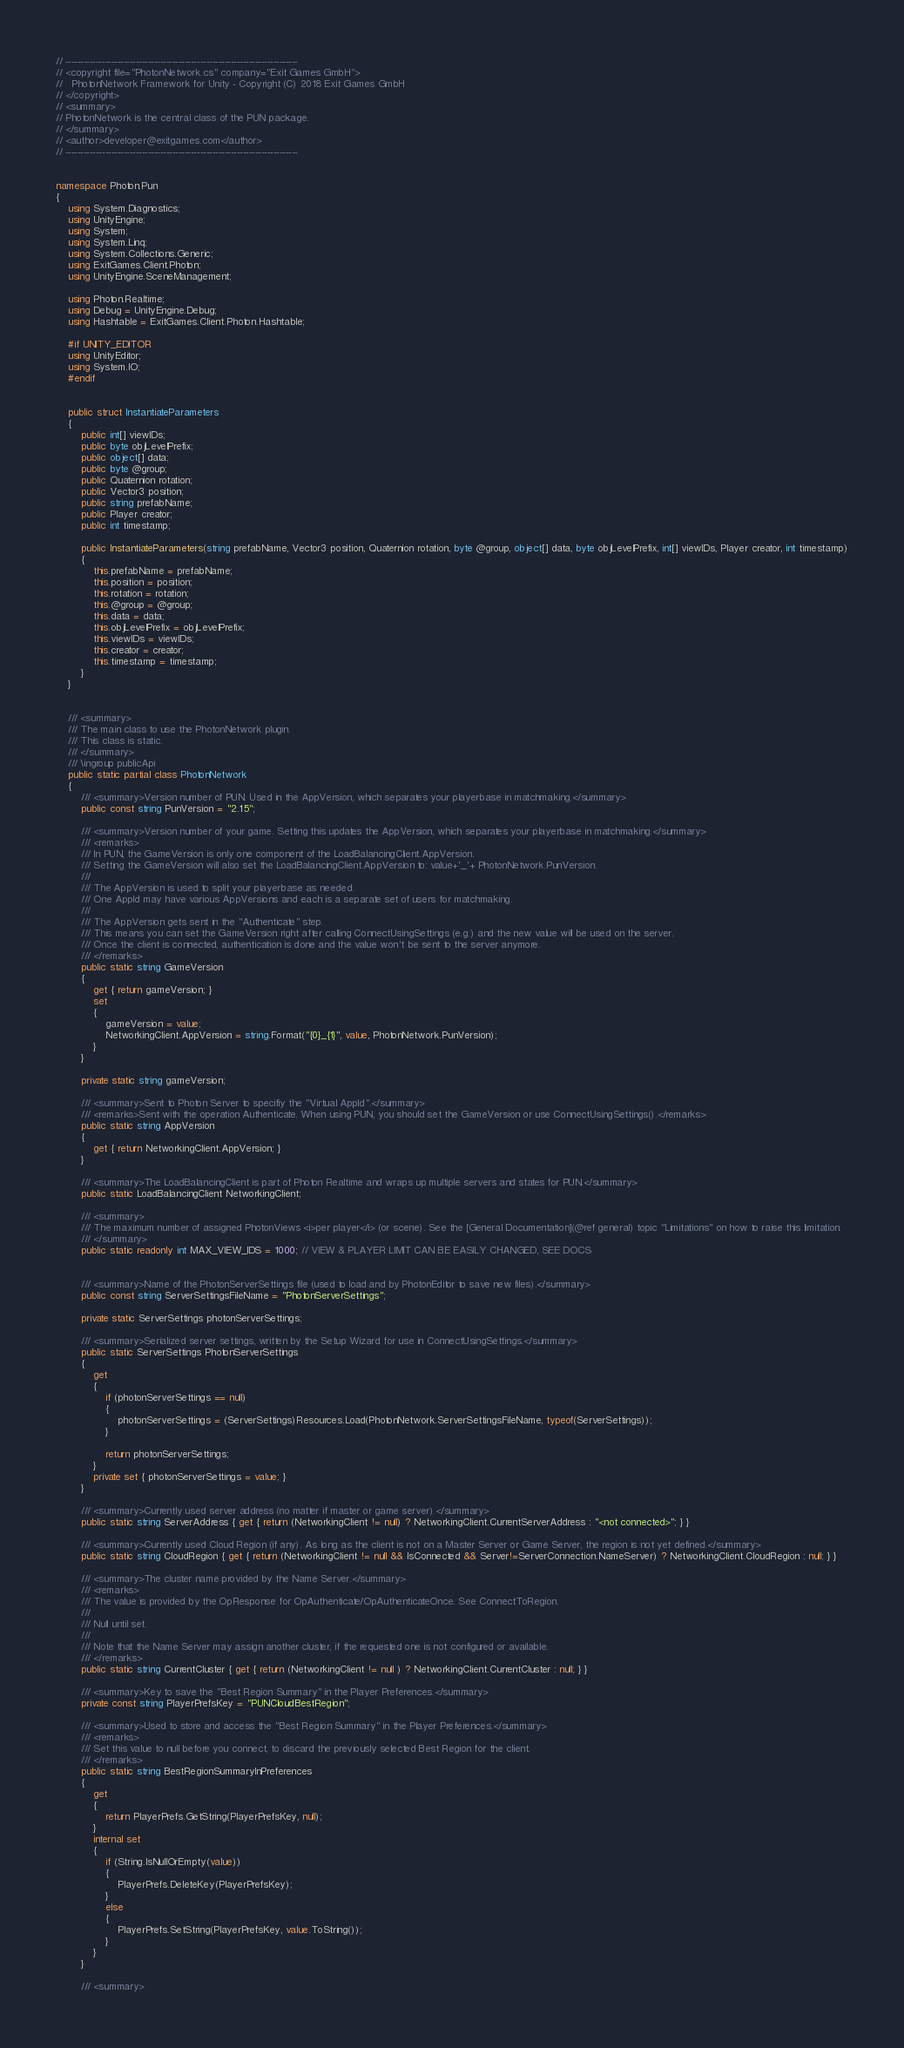Convert code to text. <code><loc_0><loc_0><loc_500><loc_500><_C#_>// ----------------------------------------------------------------------------
// <copyright file="PhotonNetwork.cs" company="Exit Games GmbH">
//   PhotonNetwork Framework for Unity - Copyright (C) 2018 Exit Games GmbH
// </copyright>
// <summary>
// PhotonNetwork is the central class of the PUN package.
// </summary>
// <author>developer@exitgames.com</author>
// ----------------------------------------------------------------------------


namespace Photon.Pun
{
    using System.Diagnostics;
    using UnityEngine;
    using System;
    using System.Linq;
    using System.Collections.Generic;
    using ExitGames.Client.Photon;
    using UnityEngine.SceneManagement;

    using Photon.Realtime;
    using Debug = UnityEngine.Debug;
    using Hashtable = ExitGames.Client.Photon.Hashtable;

    #if UNITY_EDITOR
    using UnityEditor;
    using System.IO;
    #endif


    public struct InstantiateParameters
    {
        public int[] viewIDs;
        public byte objLevelPrefix;
        public object[] data;
        public byte @group;
        public Quaternion rotation;
        public Vector3 position;
        public string prefabName;
        public Player creator;
        public int timestamp;

        public InstantiateParameters(string prefabName, Vector3 position, Quaternion rotation, byte @group, object[] data, byte objLevelPrefix, int[] viewIDs, Player creator, int timestamp)
        {
            this.prefabName = prefabName;
            this.position = position;
            this.rotation = rotation;
            this.@group = @group;
            this.data = data;
            this.objLevelPrefix = objLevelPrefix;
            this.viewIDs = viewIDs;
            this.creator = creator;
            this.timestamp = timestamp;
        }
    }


    /// <summary>
    /// The main class to use the PhotonNetwork plugin.
    /// This class is static.
    /// </summary>
    /// \ingroup publicApi
    public static partial class PhotonNetwork
    {
        /// <summary>Version number of PUN. Used in the AppVersion, which separates your playerbase in matchmaking.</summary>
        public const string PunVersion = "2.15";

        /// <summary>Version number of your game. Setting this updates the AppVersion, which separates your playerbase in matchmaking.</summary>
        /// <remarks>
        /// In PUN, the GameVersion is only one component of the LoadBalancingClient.AppVersion.
        /// Setting the GameVersion will also set the LoadBalancingClient.AppVersion to: value+'_'+ PhotonNetwork.PunVersion.
        ///
        /// The AppVersion is used to split your playerbase as needed.
        /// One AppId may have various AppVersions and each is a separate set of users for matchmaking.
        ///
        /// The AppVersion gets sent in the "Authenticate" step.
        /// This means you can set the GameVersion right after calling ConnectUsingSettings (e.g.) and the new value will be used on the server.
        /// Once the client is connected, authentication is done and the value won't be sent to the server anymore.
        /// </remarks>
        public static string GameVersion
        {
            get { return gameVersion; }
            set
            {
                gameVersion = value;
                NetworkingClient.AppVersion = string.Format("{0}_{1}", value, PhotonNetwork.PunVersion);
            }
        }

        private static string gameVersion;

        /// <summary>Sent to Photon Server to specifiy the "Virtual AppId".</summary>
        /// <remarks>Sent with the operation Authenticate. When using PUN, you should set the GameVersion or use ConnectUsingSettings().</remarks>
        public static string AppVersion
        {
            get { return NetworkingClient.AppVersion; }
        }

        /// <summary>The LoadBalancingClient is part of Photon Realtime and wraps up multiple servers and states for PUN.</summary>
        public static LoadBalancingClient NetworkingClient;

        /// <summary>
        /// The maximum number of assigned PhotonViews <i>per player</i> (or scene). See the [General Documentation](@ref general) topic "Limitations" on how to raise this limitation.
        /// </summary>
        public static readonly int MAX_VIEW_IDS = 1000; // VIEW & PLAYER LIMIT CAN BE EASILY CHANGED, SEE DOCS


        /// <summary>Name of the PhotonServerSettings file (used to load and by PhotonEditor to save new files).</summary>
        public const string ServerSettingsFileName = "PhotonServerSettings";

        private static ServerSettings photonServerSettings;

        /// <summary>Serialized server settings, written by the Setup Wizard for use in ConnectUsingSettings.</summary>
        public static ServerSettings PhotonServerSettings
        {
            get
            {
                if (photonServerSettings == null)
                {
                    photonServerSettings = (ServerSettings)Resources.Load(PhotonNetwork.ServerSettingsFileName, typeof(ServerSettings));
                }

                return photonServerSettings;
            }
            private set { photonServerSettings = value; }
        }

        /// <summary>Currently used server address (no matter if master or game server).</summary>
        public static string ServerAddress { get { return (NetworkingClient != null) ? NetworkingClient.CurrentServerAddress : "<not connected>"; } }

        /// <summary>Currently used Cloud Region (if any). As long as the client is not on a Master Server or Game Server, the region is not yet defined.</summary>
        public static string CloudRegion { get { return (NetworkingClient != null && IsConnected && Server!=ServerConnection.NameServer) ? NetworkingClient.CloudRegion : null; } }
        
        /// <summary>The cluster name provided by the Name Server.</summary>
        /// <remarks>
        /// The value is provided by the OpResponse for OpAuthenticate/OpAuthenticateOnce. See ConnectToRegion.
        /// 
        /// Null until set.
        ///
        /// Note that the Name Server may assign another cluster, if the requested one is not configured or available.
        /// </remarks>
        public static string CurrentCluster { get { return (NetworkingClient != null ) ? NetworkingClient.CurrentCluster : null; } }

        /// <summary>Key to save the "Best Region Summary" in the Player Preferences.</summary>
        private const string PlayerPrefsKey = "PUNCloudBestRegion";

        /// <summary>Used to store and access the "Best Region Summary" in the Player Preferences.</summary>
        /// <remarks>
        /// Set this value to null before you connect, to discard the previously selected Best Region for the client.
        /// </remarks>
        public static string BestRegionSummaryInPreferences
        {
            get
            {
                return PlayerPrefs.GetString(PlayerPrefsKey, null);
            }
            internal set
            {
                if (String.IsNullOrEmpty(value))
                {
                    PlayerPrefs.DeleteKey(PlayerPrefsKey);
                }
                else
                {
                    PlayerPrefs.SetString(PlayerPrefsKey, value.ToString());
                }
            }
        }

        /// <summary></code> 